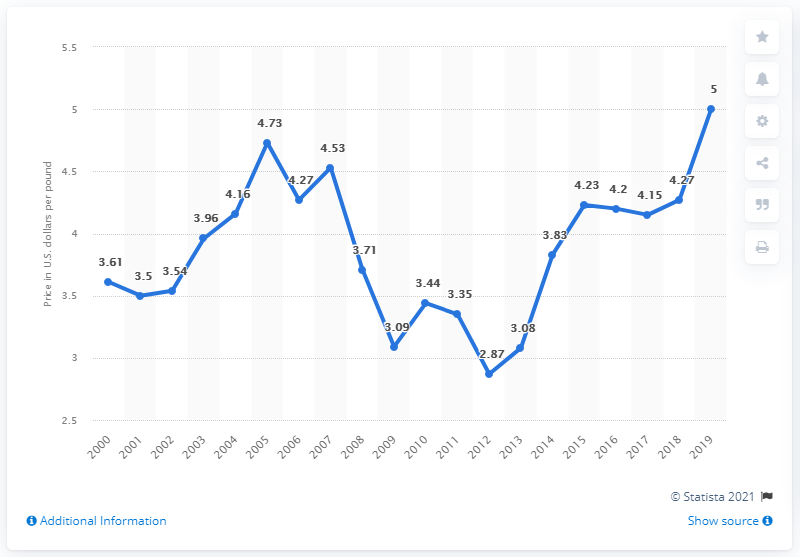Give some essential details in this illustration. In 2017, the average price per pound of American lobster was 4.15 dollars. 